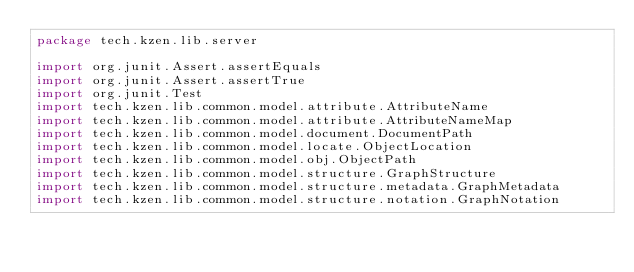Convert code to text. <code><loc_0><loc_0><loc_500><loc_500><_Kotlin_>package tech.kzen.lib.server

import org.junit.Assert.assertEquals
import org.junit.Assert.assertTrue
import org.junit.Test
import tech.kzen.lib.common.model.attribute.AttributeName
import tech.kzen.lib.common.model.attribute.AttributeNameMap
import tech.kzen.lib.common.model.document.DocumentPath
import tech.kzen.lib.common.model.locate.ObjectLocation
import tech.kzen.lib.common.model.obj.ObjectPath
import tech.kzen.lib.common.model.structure.GraphStructure
import tech.kzen.lib.common.model.structure.metadata.GraphMetadata
import tech.kzen.lib.common.model.structure.notation.GraphNotation</code> 